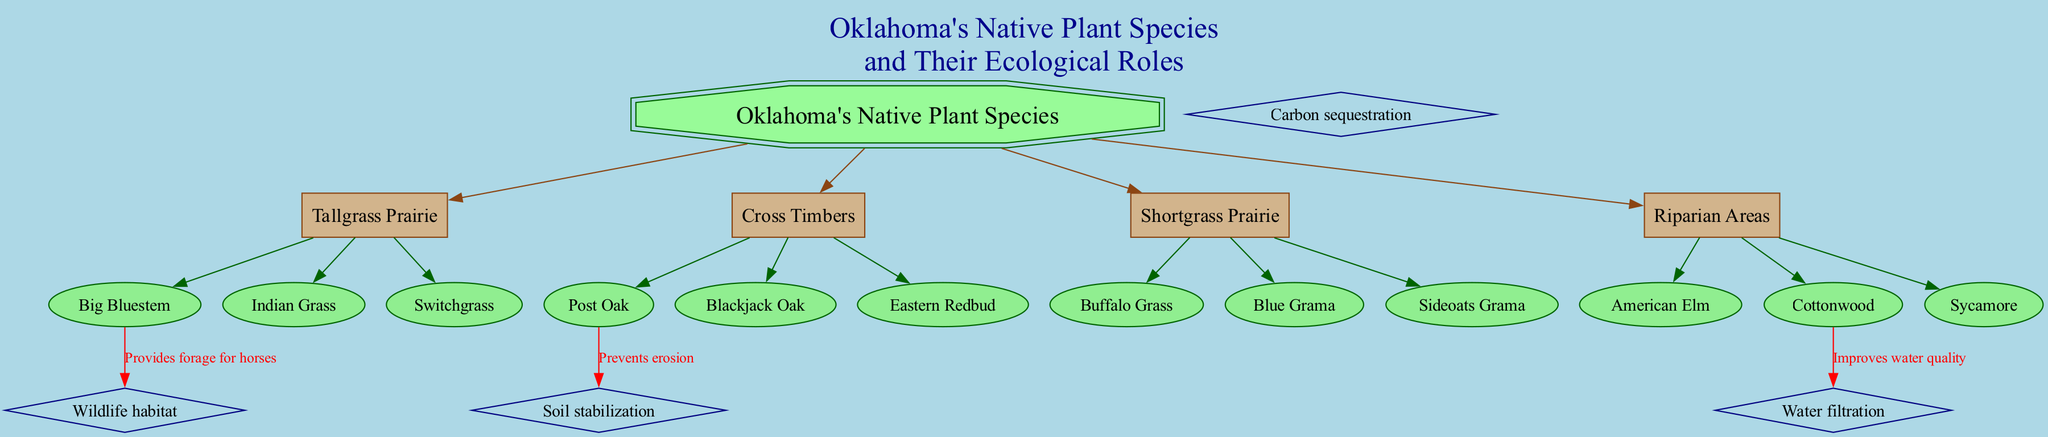What are the primary nodes in the diagram? The primary nodes are listed under the "primaryNodes" section. They are Tallgrass Prairie, Cross Timbers, Shortgrass Prairie, and Riparian Areas.
Answer: Tallgrass Prairie, Cross Timbers, Shortgrass Prairie, Riparian Areas How many secondary nodes are associated with Tallgrass Prairie? By examining the "secondaryNodes" for Tallgrass Prairie, we see it includes three secondary nodes: Big Bluestem, Indian Grass, and Switchgrass.
Answer: 3 Which plant species provides forage for horses? The connection labeled "Provides forage for horses" originates from Big Bluestem, indicating that it specifically offers forage suitable for horses.
Answer: Big Bluestem What ecological role is associated with Post Oak? Looking at the connections from Post Oak, the role it plays is "Soil stabilization," which prevents erosion.
Answer: Soil stabilization Which plant improves water quality? In the connections, Cottonwood is linked to the ecological role of "Water filtration," therefore it improves water quality.
Answer: Cottonwood How many total ecological roles are identified in the diagram? The ecological roles are outlined in the "ecologicalRoles" section, where we find four identified roles: Soil stabilization, Wildlife habitat, Carbon sequestration, and Water filtration.
Answer: 4 Which plant is connected to carbon sequestration? The diagram does not specify a direct connection of any plant with the ecological role of carbon sequestration. Therefore, the answer is that no plant is directly linked to this role.
Answer: None What role does Big Bluestem play ecologically? Big Bluestem is specifically mentioned to provide wildlife habitat through the connection labeled "Provides forage for horses."
Answer: Wildlife habitat What is the color of the central node? The central node is described with specific attributes; it has a fill color labeled as "palegreen."
Answer: palegreen 